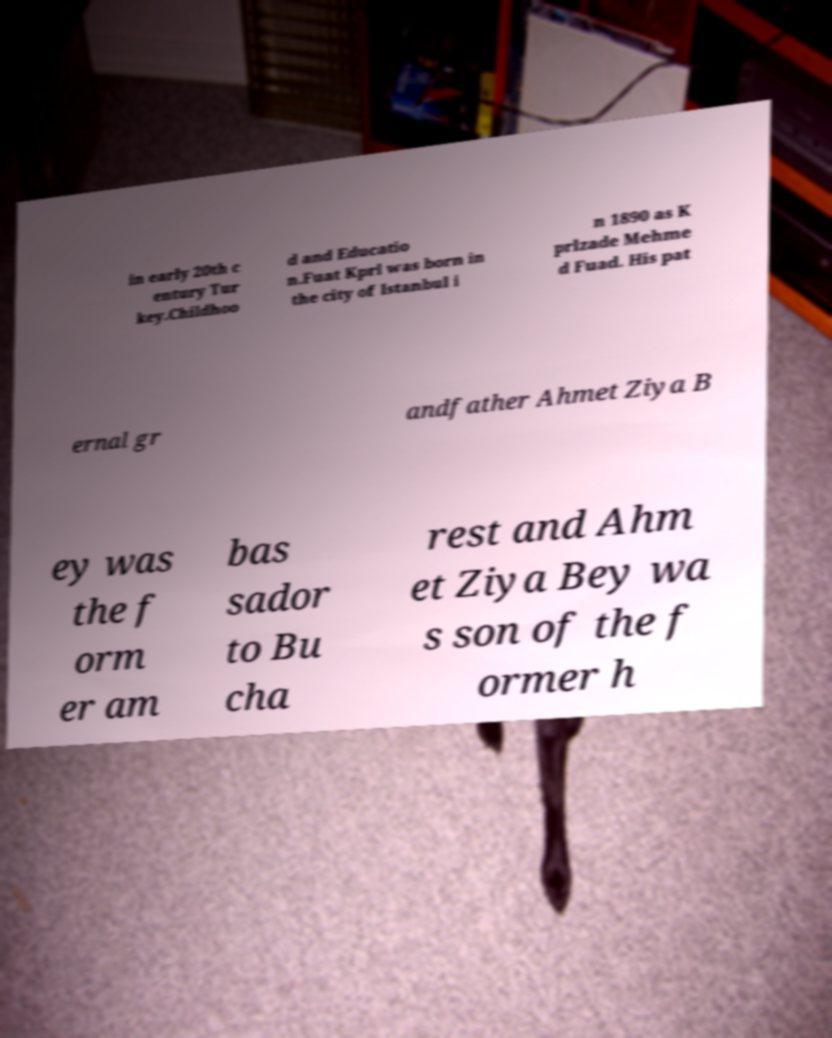Please identify and transcribe the text found in this image. in early 20th c entury Tur key.Childhoo d and Educatio n.Fuat Kprl was born in the city of Istanbul i n 1890 as K prlzade Mehme d Fuad. His pat ernal gr andfather Ahmet Ziya B ey was the f orm er am bas sador to Bu cha rest and Ahm et Ziya Bey wa s son of the f ormer h 